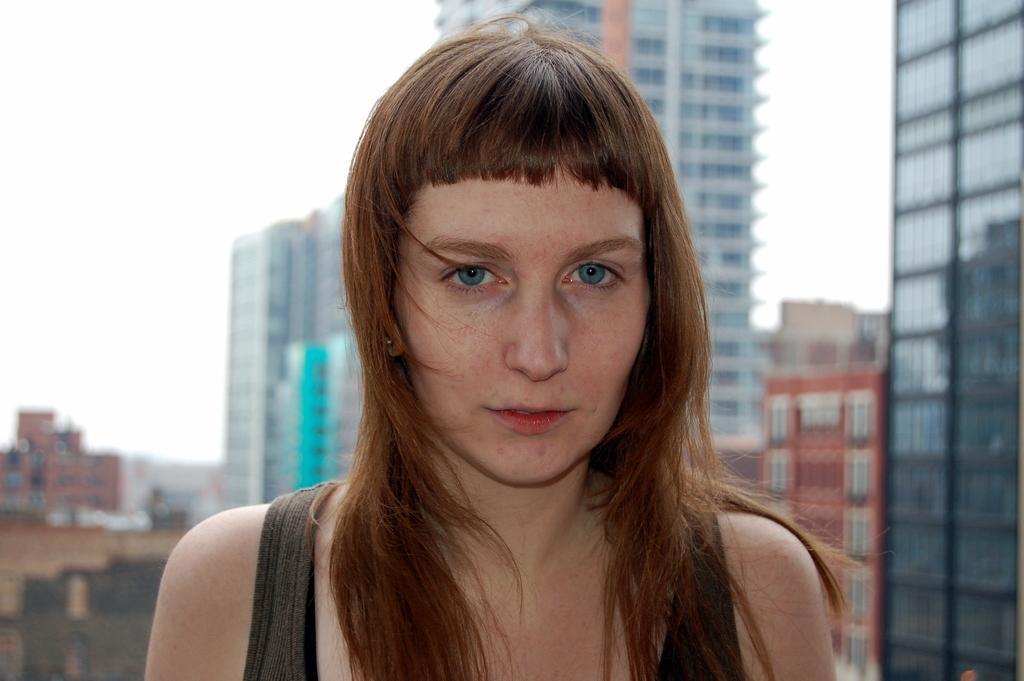Please provide a concise description of this image. In this picture I can see a woman, there are buildings, and in the background there is the sky. 